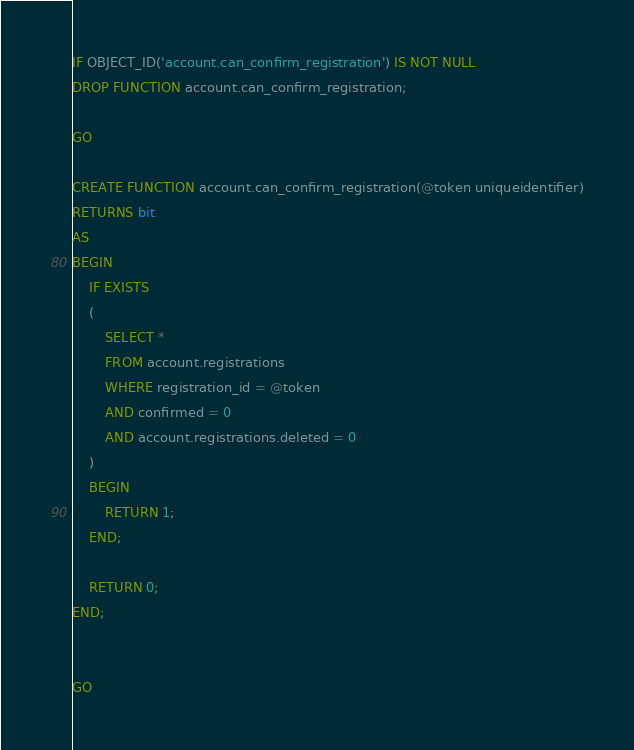Convert code to text. <code><loc_0><loc_0><loc_500><loc_500><_SQL_>IF OBJECT_ID('account.can_confirm_registration') IS NOT NULL
DROP FUNCTION account.can_confirm_registration;

GO

CREATE FUNCTION account.can_confirm_registration(@token uniqueidentifier)
RETURNS bit
AS
BEGIN
    IF EXISTS
    (
        SELECT *
        FROM account.registrations
        WHERE registration_id = @token
        AND confirmed = 0
		AND account.registrations.deleted = 0
    )
    BEGIN
        RETURN 1;
    END;

    RETURN 0;
END;


GO
</code> 